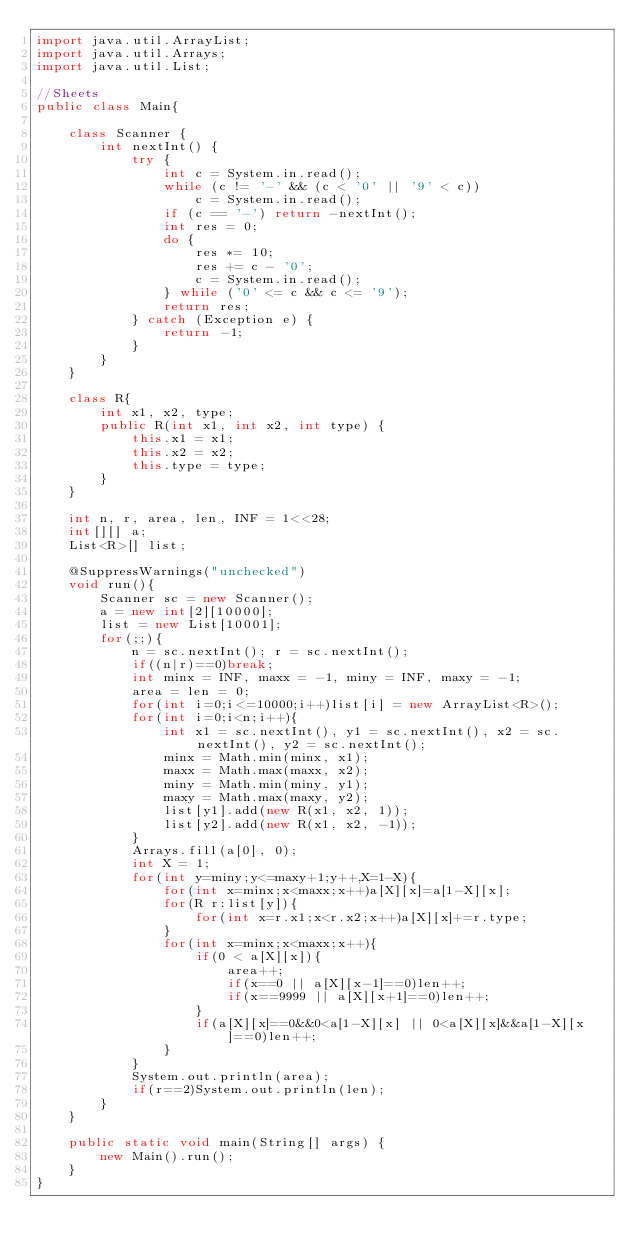Convert code to text. <code><loc_0><loc_0><loc_500><loc_500><_Java_>import java.util.ArrayList;
import java.util.Arrays;
import java.util.List;

//Sheets
public class Main{

	class Scanner {
		int nextInt() {
			try {
				int c = System.in.read();
				while (c != '-' && (c < '0' || '9' < c))
					c = System.in.read();
				if (c == '-') return -nextInt();
				int res = 0;
				do {
					res *= 10;
					res += c - '0';
					c = System.in.read();
				} while ('0' <= c && c <= '9');
				return res;
			} catch (Exception e) {
				return -1;
			}
		}
	}
	
	class R{
		int x1, x2, type;
		public R(int x1, int x2, int type) {
			this.x1 = x1;
			this.x2 = x2;
			this.type = type;
		}
	}
	
	int n, r, area, len, INF = 1<<28;
	int[][] a;
	List<R>[] list;
	
	@SuppressWarnings("unchecked")
	void run(){
		Scanner sc = new Scanner();
		a = new int[2][10000];
		list = new List[10001];
		for(;;){
			n = sc.nextInt(); r = sc.nextInt();
			if((n|r)==0)break;
			int minx = INF, maxx = -1, miny = INF, maxy = -1;
			area = len = 0;
			for(int i=0;i<=10000;i++)list[i] = new ArrayList<R>();
			for(int i=0;i<n;i++){
				int x1 = sc.nextInt(), y1 = sc.nextInt(), x2 = sc.nextInt(), y2 = sc.nextInt();
				minx = Math.min(minx, x1);
				maxx = Math.max(maxx, x2);
				miny = Math.min(miny, y1);
				maxy = Math.max(maxy, y2);
				list[y1].add(new R(x1, x2, 1));
				list[y2].add(new R(x1, x2, -1));
			}
			Arrays.fill(a[0], 0);
			int X = 1;
			for(int y=miny;y<=maxy+1;y++,X=1-X){
				for(int x=minx;x<maxx;x++)a[X][x]=a[1-X][x];
				for(R r:list[y]){
					for(int x=r.x1;x<r.x2;x++)a[X][x]+=r.type;
				}
				for(int x=minx;x<maxx;x++){
					if(0 < a[X][x]){
						area++;
						if(x==0 || a[X][x-1]==0)len++;
						if(x==9999 || a[X][x+1]==0)len++;
					}
					if(a[X][x]==0&&0<a[1-X][x] || 0<a[X][x]&&a[1-X][x]==0)len++;
				}
			}
			System.out.println(area);
			if(r==2)System.out.println(len);
		}
	}
	
	public static void main(String[] args) {
		new Main().run();
	}
}</code> 